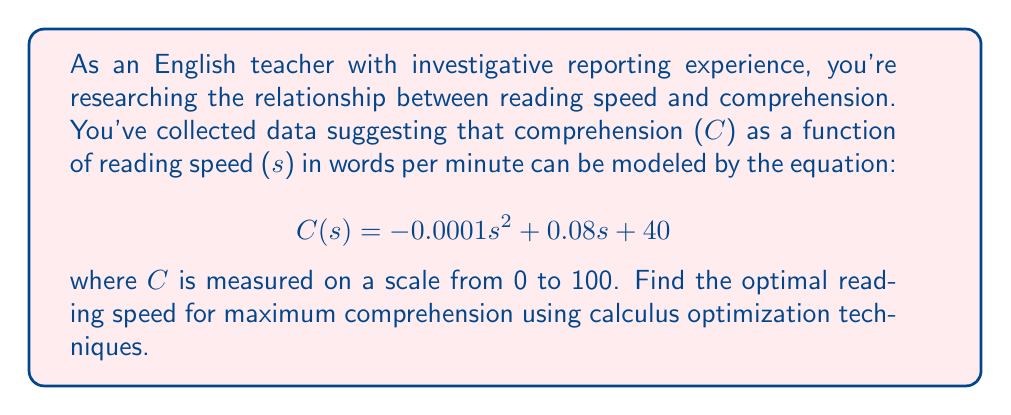Provide a solution to this math problem. To find the optimal reading speed for maximum comprehension, we need to find the maximum value of the function C(s). This can be done by following these steps:

1. Find the derivative of C(s):
   $$\frac{dC}{ds} = -0.0002s + 0.08$$

2. Set the derivative equal to zero and solve for s:
   $$-0.0002s + 0.08 = 0$$
   $$-0.0002s = -0.08$$
   $$s = \frac{-0.08}{-0.0002} = 400$$

3. Verify that this critical point is a maximum by checking the second derivative:
   $$\frac{d^2C}{ds^2} = -0.0002$$
   Since the second derivative is negative, the critical point is a maximum.

4. Calculate the maximum comprehension:
   $$C(400) = -0.0001(400)^2 + 0.08(400) + 40$$
   $$= -16 + 32 + 40 = 56$$

Therefore, the optimal reading speed for maximum comprehension is 400 words per minute, resulting in a comprehension score of 56 out of 100.
Answer: The optimal reading speed is 400 words per minute, yielding a maximum comprehension score of 56 out of 100. 